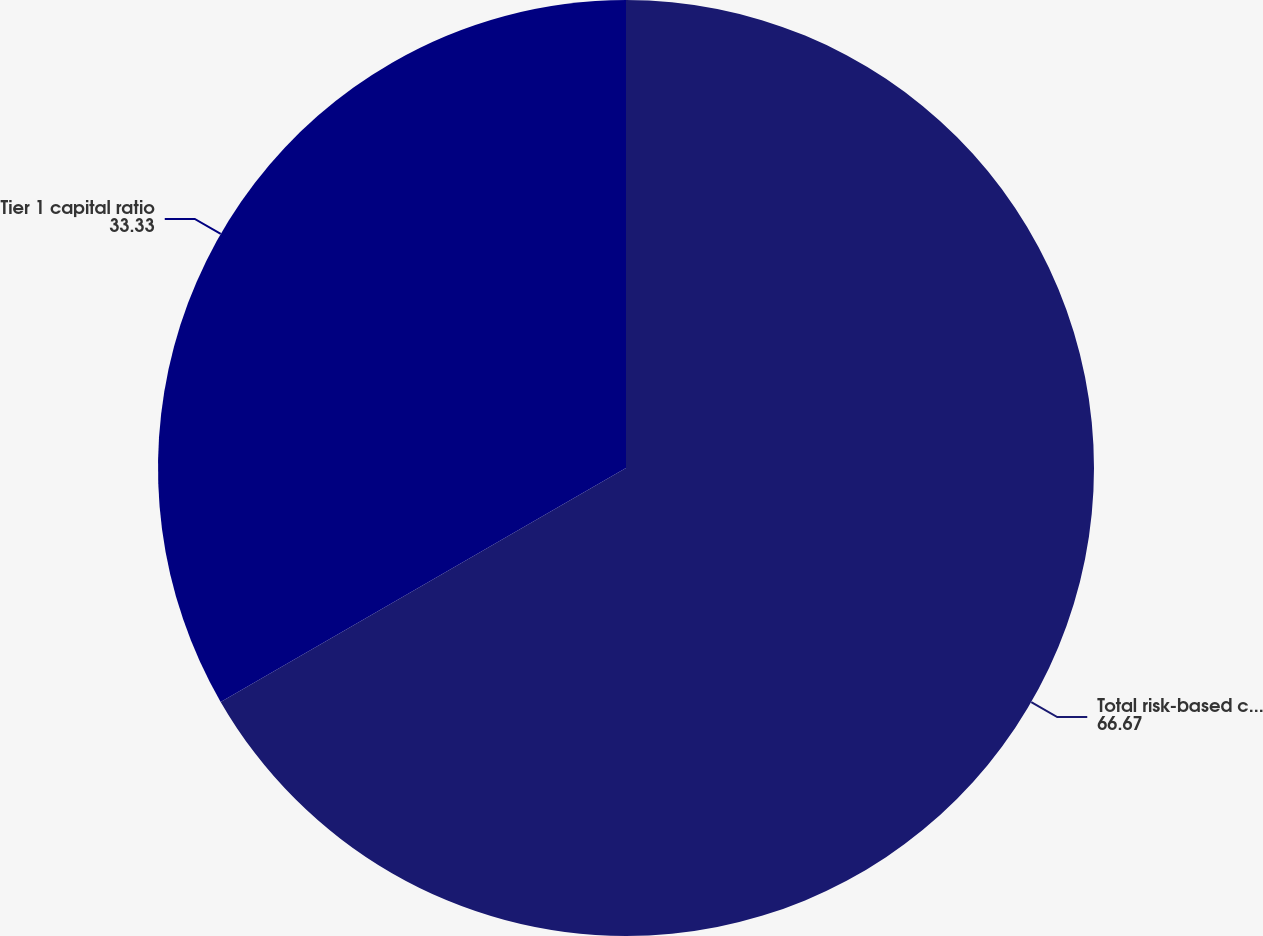Convert chart to OTSL. <chart><loc_0><loc_0><loc_500><loc_500><pie_chart><fcel>Total risk-based capital ratio<fcel>Tier 1 capital ratio<nl><fcel>66.67%<fcel>33.33%<nl></chart> 